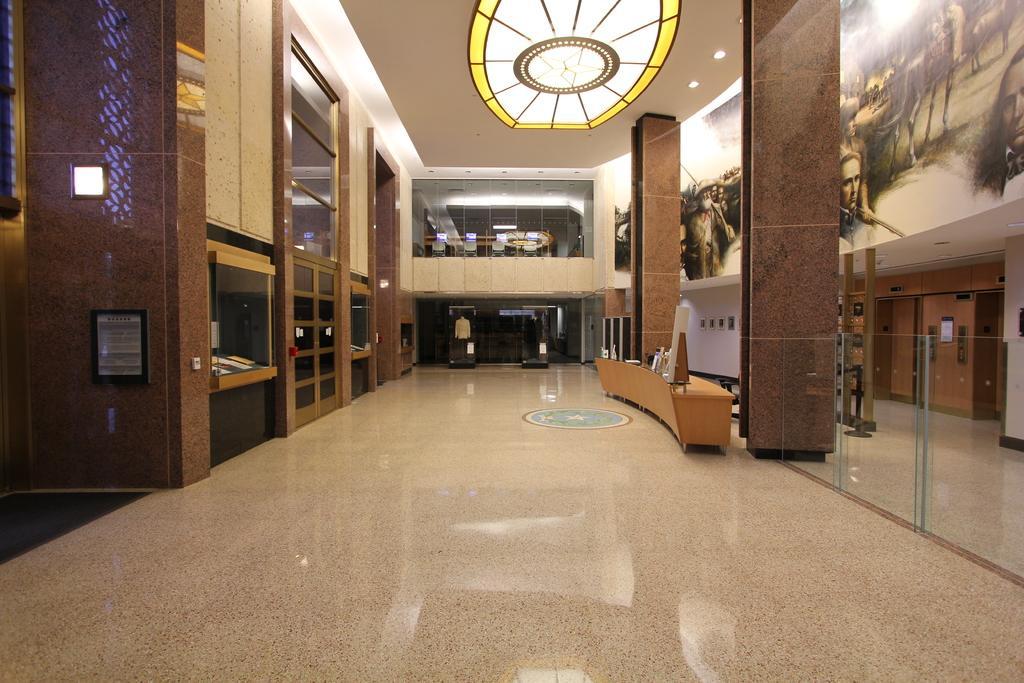In one or two sentences, can you explain what this image depicts? The image is taken in the hall. On the right side of the image there is a table. At the top there is light. On the left we can see a shelf. 